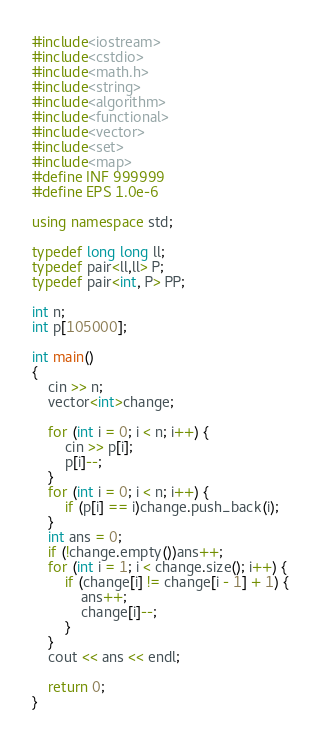<code> <loc_0><loc_0><loc_500><loc_500><_C++_>#include<iostream>
#include<cstdio>
#include<math.h>
#include<string>
#include<algorithm>
#include<functional>
#include<vector>
#include<set>
#include<map>
#define INF 999999
#define EPS 1.0e-6

using namespace std;

typedef long long ll;
typedef pair<ll,ll> P;
typedef pair<int, P> PP;

int n;
int p[105000];

int main()
{
	cin >> n;
	vector<int>change;
	
	for (int i = 0; i < n; i++) {
		cin >> p[i];
		p[i]--;
	}
	for (int i = 0; i < n; i++) {
		if (p[i] == i)change.push_back(i);
	}
	int ans = 0;
	if (!change.empty())ans++;
	for (int i = 1; i < change.size(); i++) {
		if (change[i] != change[i - 1] + 1) {
			ans++;
			change[i]--;
		}
	}
	cout << ans << endl;

	return 0;
}</code> 